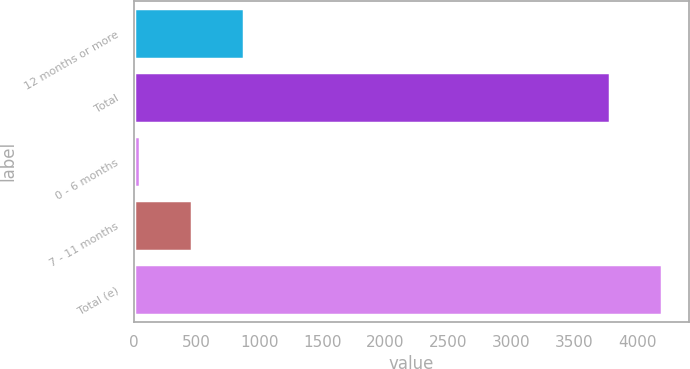Convert chart to OTSL. <chart><loc_0><loc_0><loc_500><loc_500><bar_chart><fcel>12 months or more<fcel>Total<fcel>0 - 6 months<fcel>7 - 11 months<fcel>Total (e)<nl><fcel>879.8<fcel>3784<fcel>52<fcel>465.9<fcel>4197.9<nl></chart> 